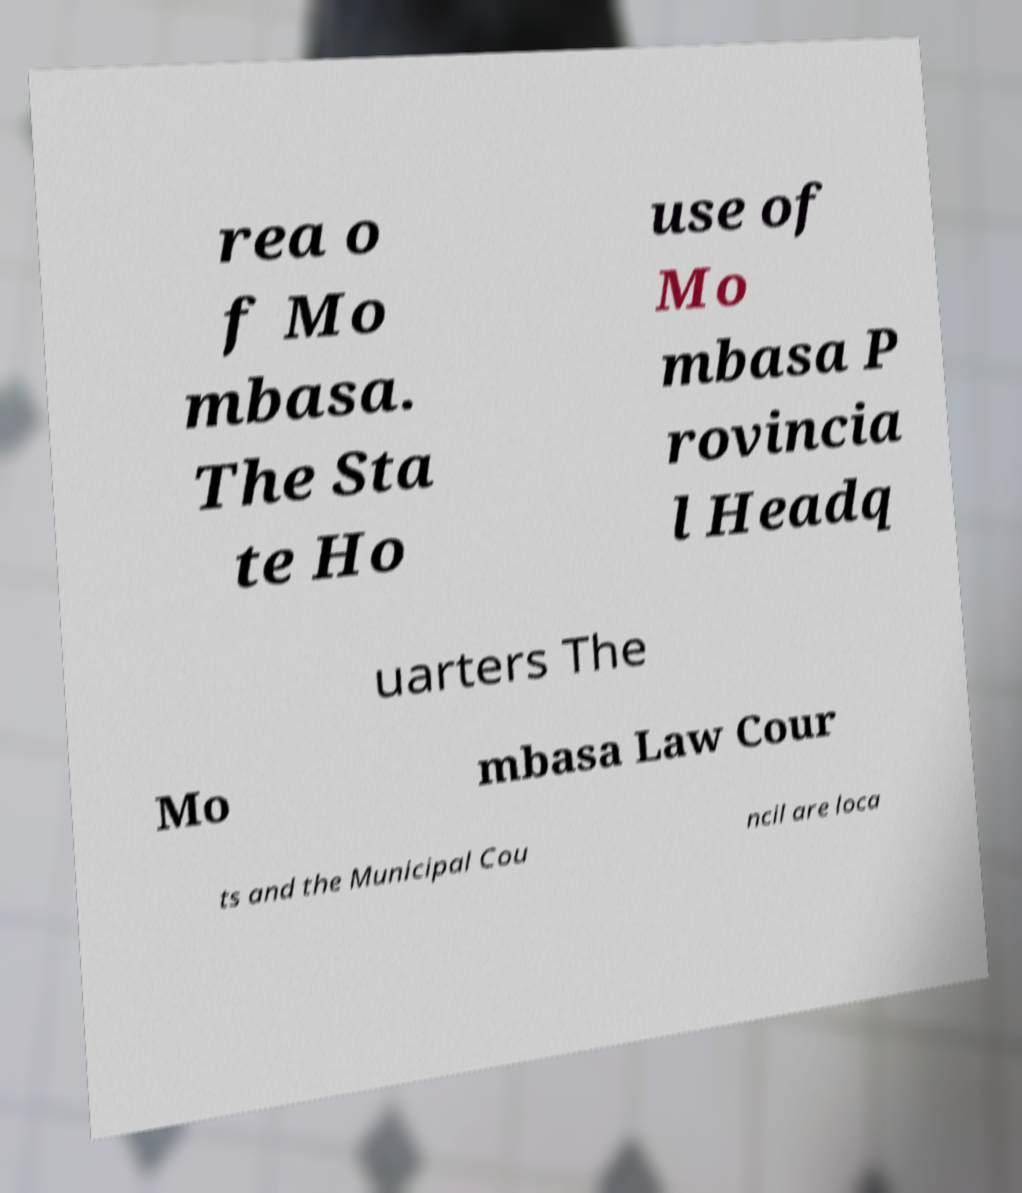Please read and relay the text visible in this image. What does it say? rea o f Mo mbasa. The Sta te Ho use of Mo mbasa P rovincia l Headq uarters The Mo mbasa Law Cour ts and the Municipal Cou ncil are loca 